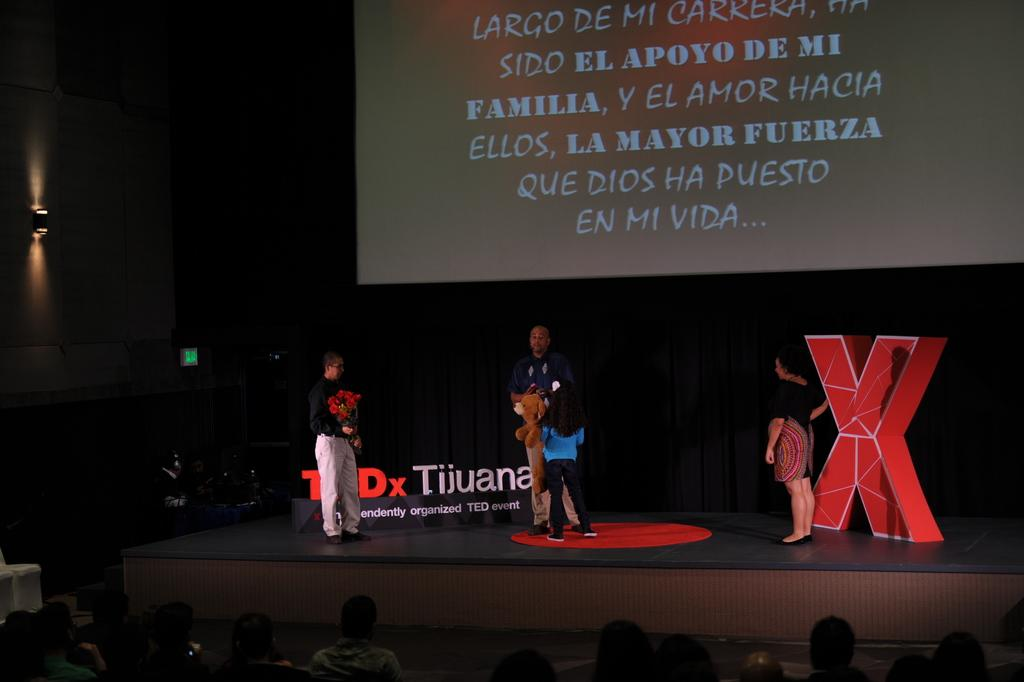How many people are on the dais in the image? There are four people on the dais in the image. What can be seen in the background behind the dais? There is a screen in the background. What is happening at the bottom of the image? There is a crowd at the bottom of the image. What is located to the left of the dais? There is a wall to the left with a light on it. What type of coat is being worn by the person in the image? There is no person wearing a coat in the image. What kind of waste can be seen on the ground in the image? There is no waste visible on the ground in the image. 